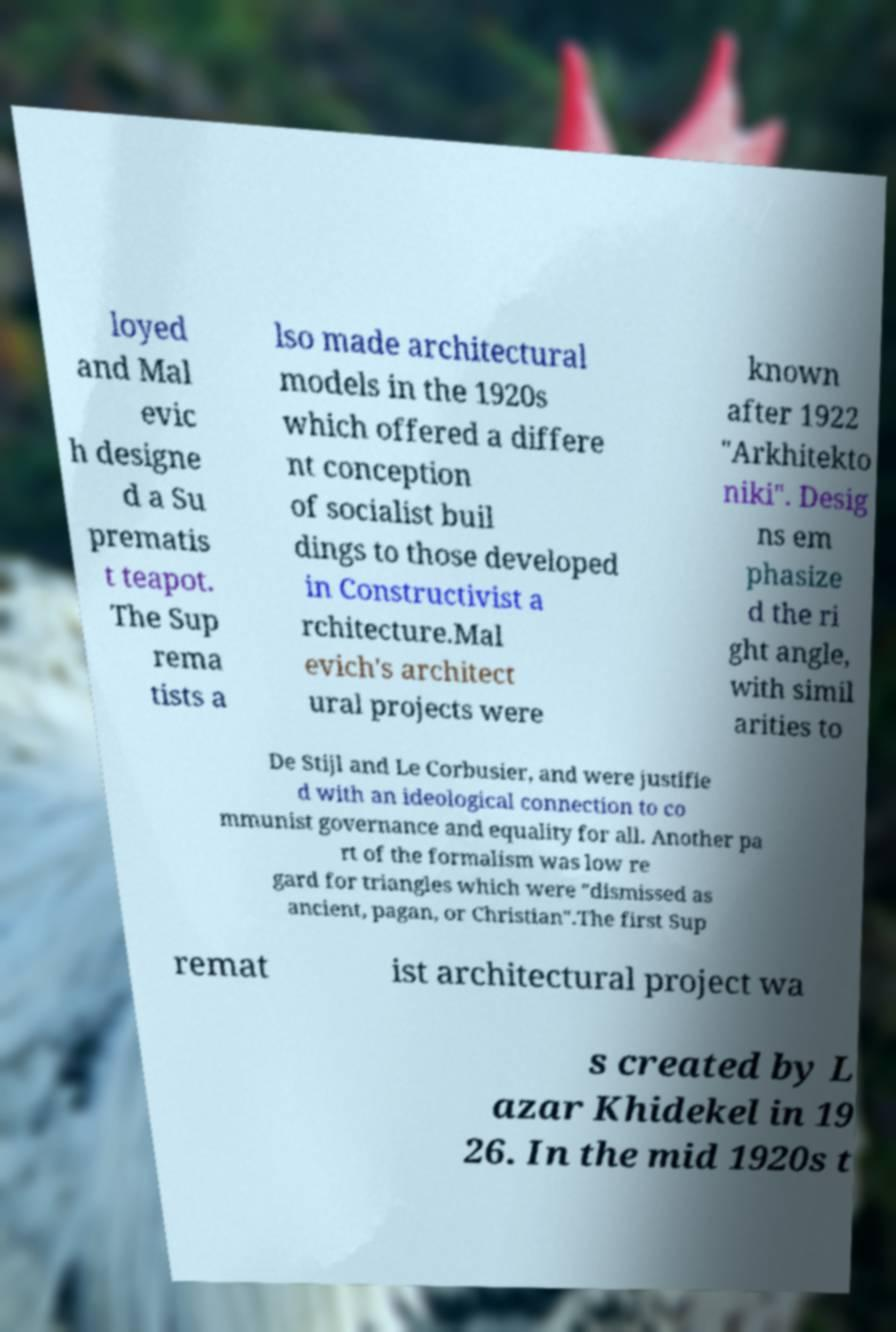What messages or text are displayed in this image? I need them in a readable, typed format. loyed and Mal evic h designe d a Su prematis t teapot. The Sup rema tists a lso made architectural models in the 1920s which offered a differe nt conception of socialist buil dings to those developed in Constructivist a rchitecture.Mal evich's architect ural projects were known after 1922 "Arkhitekto niki". Desig ns em phasize d the ri ght angle, with simil arities to De Stijl and Le Corbusier, and were justifie d with an ideological connection to co mmunist governance and equality for all. Another pa rt of the formalism was low re gard for triangles which were "dismissed as ancient, pagan, or Christian".The first Sup remat ist architectural project wa s created by L azar Khidekel in 19 26. In the mid 1920s t 